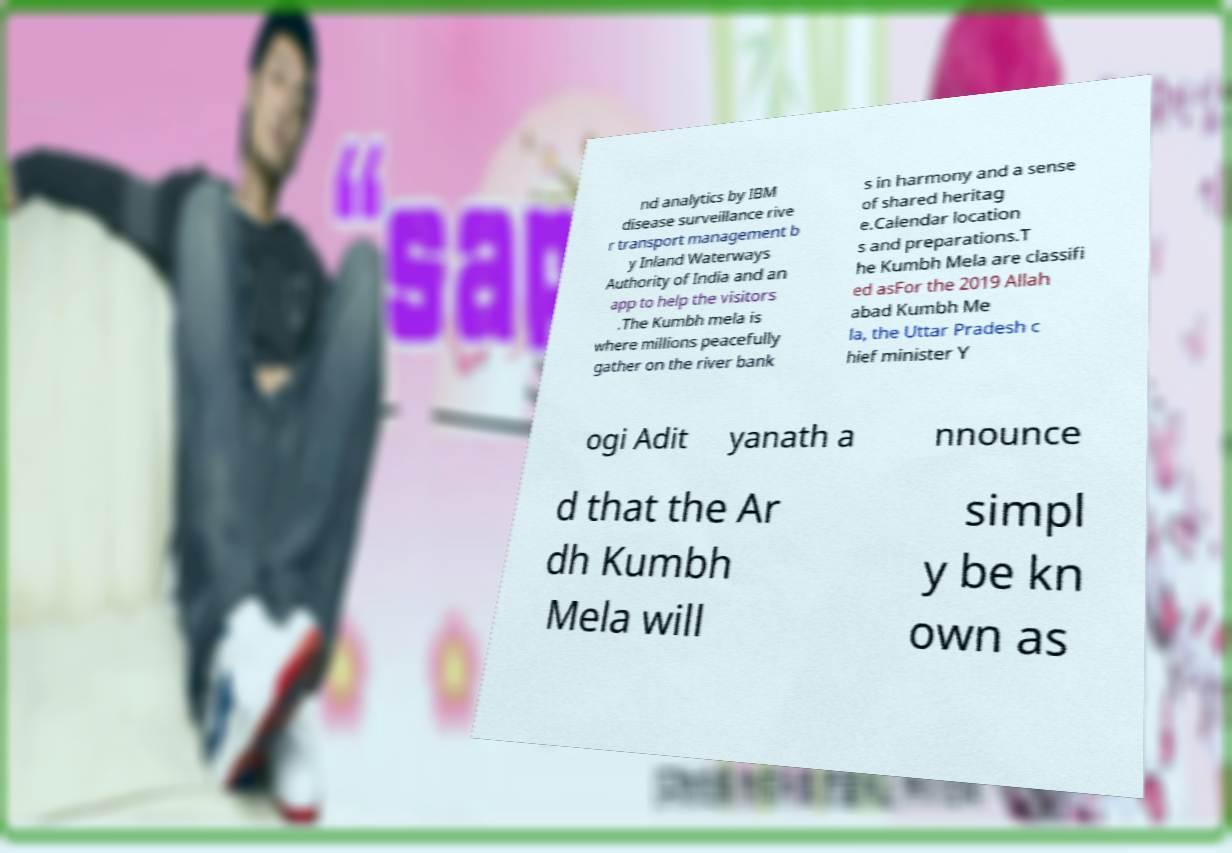I need the written content from this picture converted into text. Can you do that? nd analytics by IBM disease surveillance rive r transport management b y Inland Waterways Authority of India and an app to help the visitors .The Kumbh mela is where millions peacefully gather on the river bank s in harmony and a sense of shared heritag e.Calendar location s and preparations.T he Kumbh Mela are classifi ed asFor the 2019 Allah abad Kumbh Me la, the Uttar Pradesh c hief minister Y ogi Adit yanath a nnounce d that the Ar dh Kumbh Mela will simpl y be kn own as 